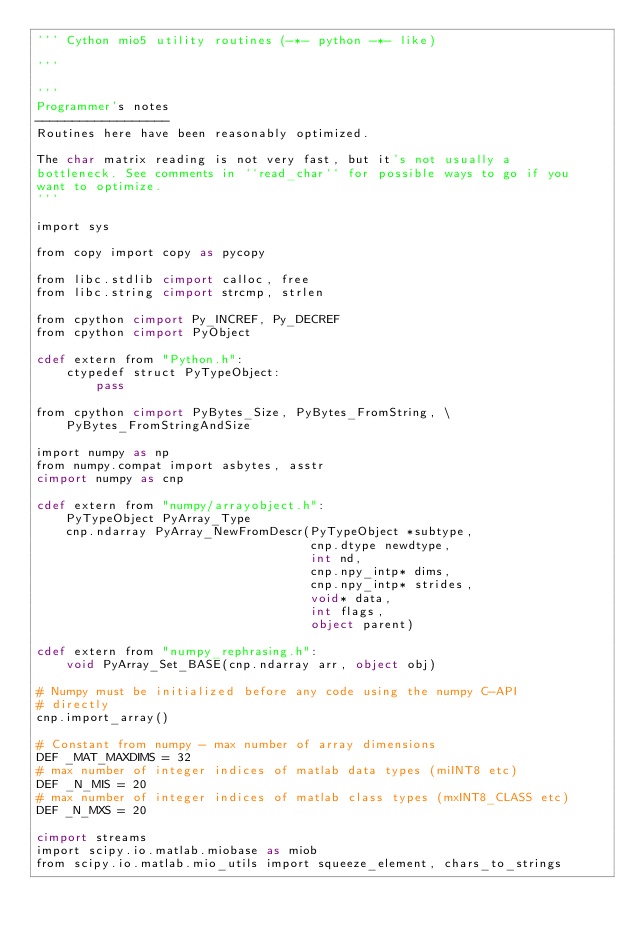Convert code to text. <code><loc_0><loc_0><loc_500><loc_500><_Cython_>''' Cython mio5 utility routines (-*- python -*- like)

'''

'''
Programmer's notes
------------------
Routines here have been reasonably optimized.

The char matrix reading is not very fast, but it's not usually a
bottleneck. See comments in ``read_char`` for possible ways to go if you
want to optimize.
'''

import sys

from copy import copy as pycopy

from libc.stdlib cimport calloc, free
from libc.string cimport strcmp, strlen

from cpython cimport Py_INCREF, Py_DECREF
from cpython cimport PyObject

cdef extern from "Python.h":
    ctypedef struct PyTypeObject:
        pass

from cpython cimport PyBytes_Size, PyBytes_FromString, \
    PyBytes_FromStringAndSize

import numpy as np
from numpy.compat import asbytes, asstr
cimport numpy as cnp

cdef extern from "numpy/arrayobject.h":
    PyTypeObject PyArray_Type
    cnp.ndarray PyArray_NewFromDescr(PyTypeObject *subtype,
                                     cnp.dtype newdtype,
                                     int nd,
                                     cnp.npy_intp* dims,
                                     cnp.npy_intp* strides,
                                     void* data,
                                     int flags,
                                     object parent)

cdef extern from "numpy_rephrasing.h":
    void PyArray_Set_BASE(cnp.ndarray arr, object obj)

# Numpy must be initialized before any code using the numpy C-API
# directly
cnp.import_array()

# Constant from numpy - max number of array dimensions
DEF _MAT_MAXDIMS = 32
# max number of integer indices of matlab data types (miINT8 etc)
DEF _N_MIS = 20
# max number of integer indices of matlab class types (mxINT8_CLASS etc)
DEF _N_MXS = 20

cimport streams
import scipy.io.matlab.miobase as miob
from scipy.io.matlab.mio_utils import squeeze_element, chars_to_strings</code> 